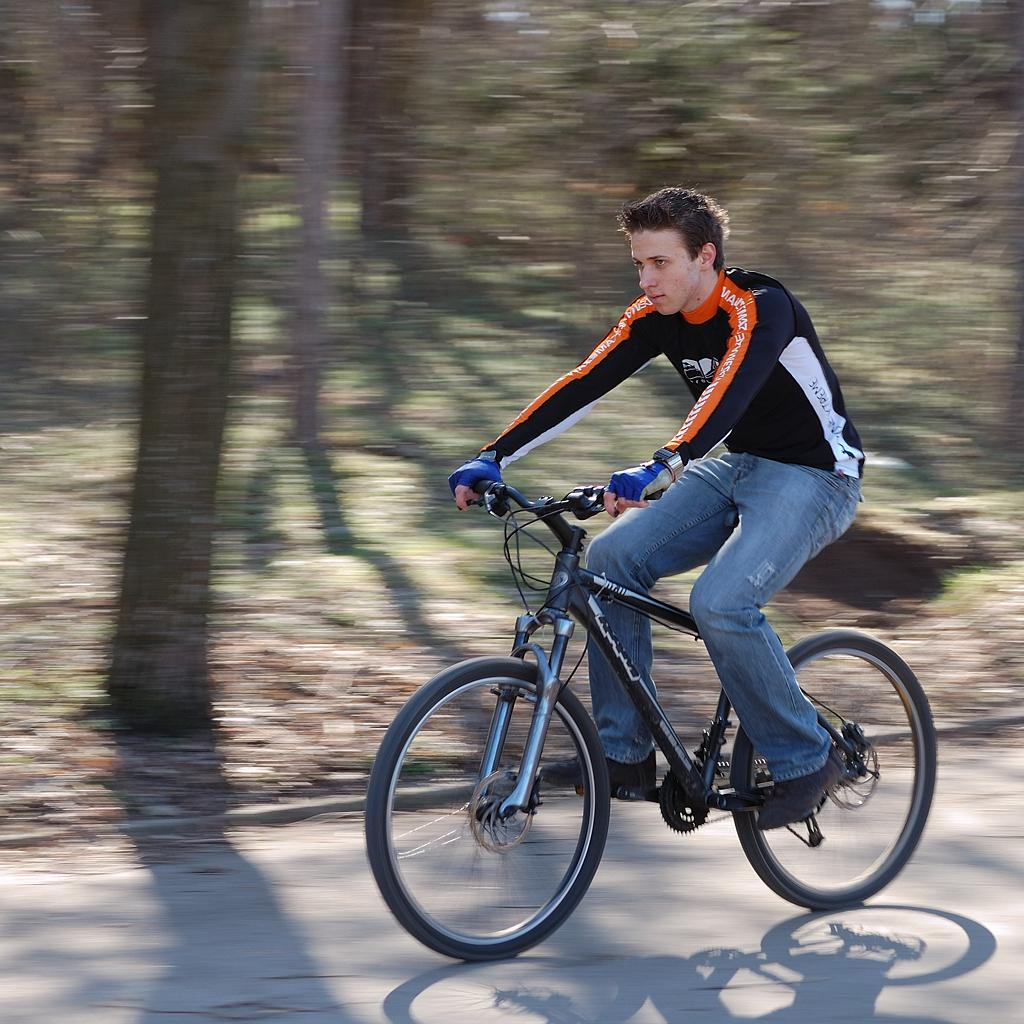What is the main subject of the image? There is a person in the image. What is the person doing in the image? The person is riding a bicycle. Where is the bicycle located? The bicycle is on a road. What is the purpose of the joke being told by the person on the bicycle in the image? There is no joke being told by the person in the image; they are simply riding a bicycle. 